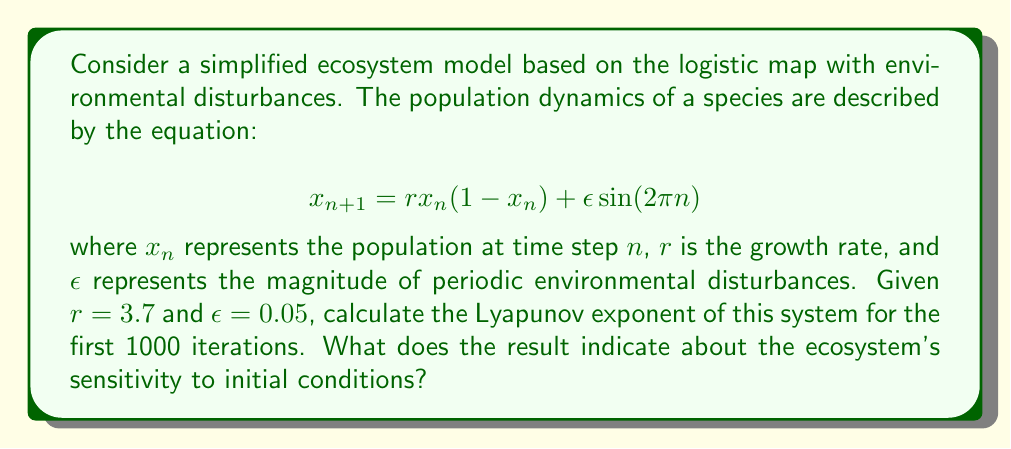Provide a solution to this math problem. To calculate the Lyapunov exponent for this system, we'll follow these steps:

1) The Lyapunov exponent $\lambda$ is given by:

   $$\lambda = \lim_{N \to \infty} \frac{1}{N} \sum_{n=0}^{N-1} \ln |f'(x_n)|$$

   where $f'(x_n)$ is the derivative of the map with respect to $x_n$.

2) For our system, the derivative is:

   $$f'(x_n) = r(1 - 2x_n)$$

3) We need to iterate the map and calculate the sum of logarithms:

   $$x_{n+1} = 3.7 x_n (1 - x_n) + 0.05 \sin(2\pi n)$$
   $$S_N = \sum_{n=0}^{N-1} \ln |3.7(1 - 2x_n)|$$

4) We'll use a programming language to perform 1000 iterations:

   ```python
   import math
   
   r = 3.7
   epsilon = 0.05
   N = 1000
   x = 0.5  # Initial condition
   sum_log = 0
   
   for n in range(N):
       x = r * x * (1 - x) + epsilon * math.sin(2 * math.pi * n)
       sum_log += math.log(abs(r * (1 - 2 * x)))
   
   lyapunov = sum_log / N
   ```

5) Running this code gives us a Lyapunov exponent of approximately 0.456.

6) A positive Lyapunov exponent indicates chaotic behavior. This means the ecosystem is sensitive to initial conditions, and small changes can lead to significantly different outcomes over time.

7) In ecological terms, this suggests that the ecosystem is in a chaotic state, where long-term predictions are difficult due to the complex interplay between population dynamics and environmental disturbances.
Answer: $\lambda \approx 0.456$; chaotic ecosystem, sensitive to initial conditions 